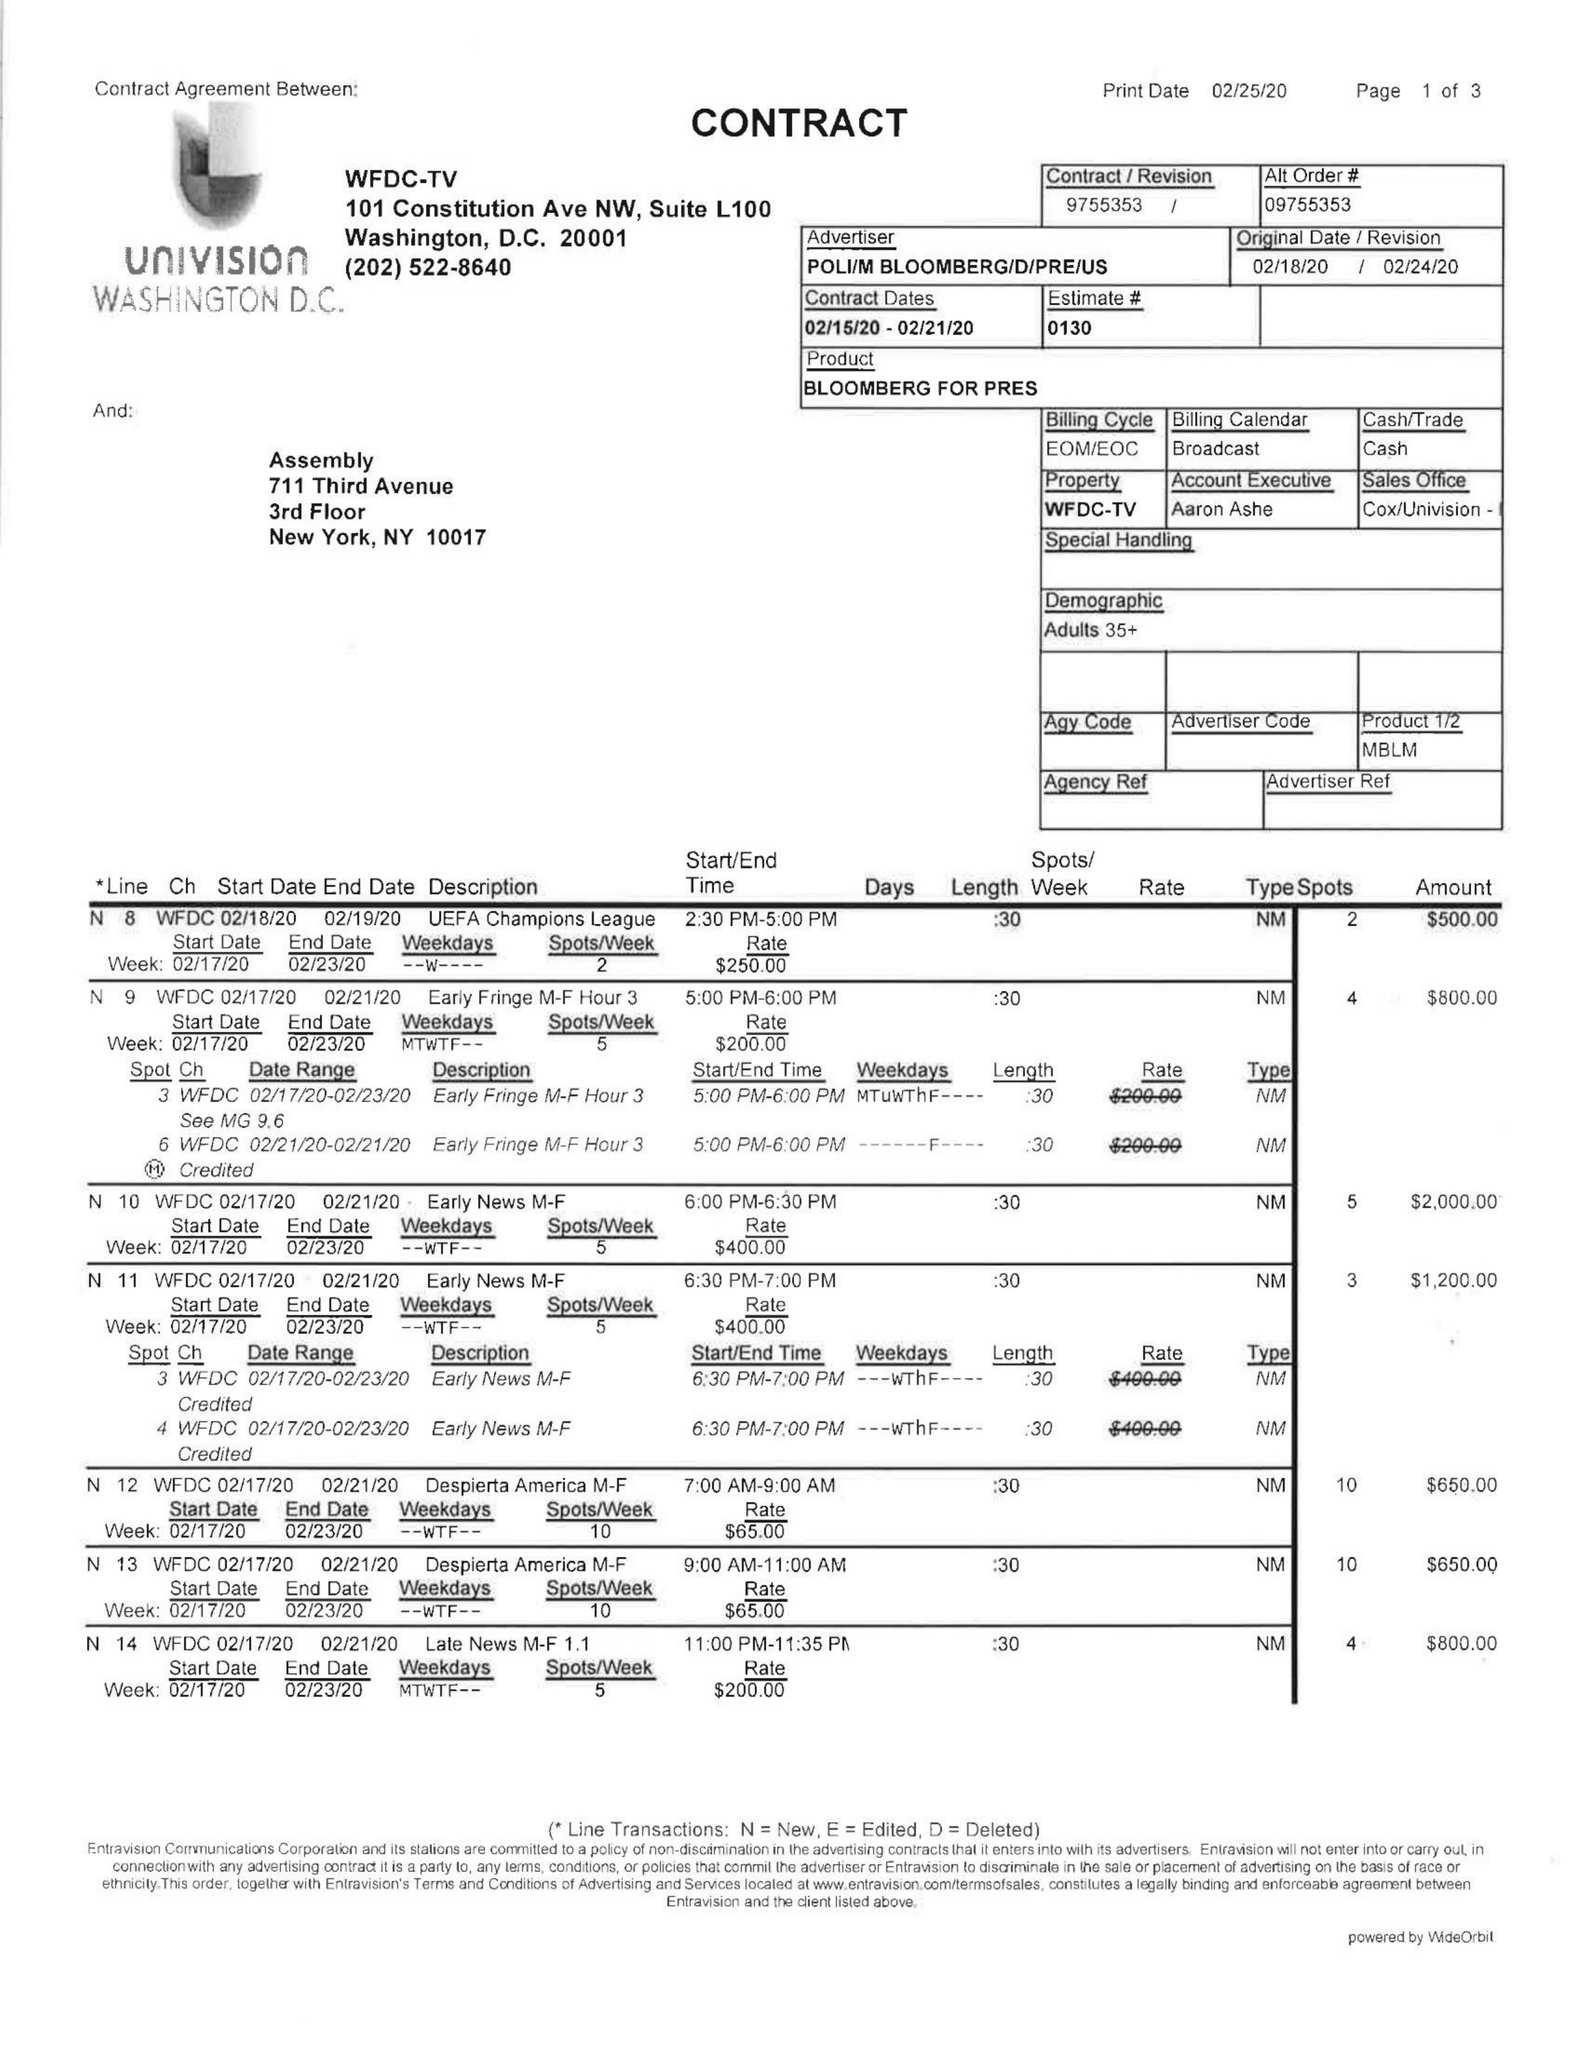What is the value for the flight_from?
Answer the question using a single word or phrase. 02/15/20 